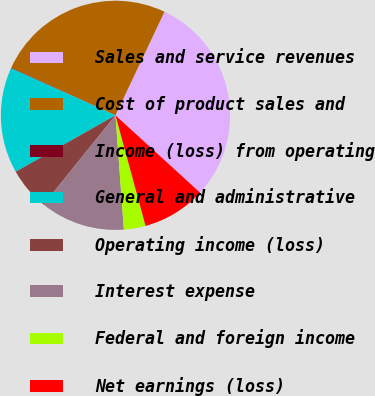Convert chart. <chart><loc_0><loc_0><loc_500><loc_500><pie_chart><fcel>Sales and service revenues<fcel>Cost of product sales and<fcel>Income (loss) from operating<fcel>General and administrative<fcel>Operating income (loss)<fcel>Interest expense<fcel>Federal and foreign income<fcel>Net earnings (loss)<nl><fcel>29.75%<fcel>25.21%<fcel>0.09%<fcel>14.92%<fcel>6.02%<fcel>11.96%<fcel>3.06%<fcel>8.99%<nl></chart> 